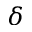<formula> <loc_0><loc_0><loc_500><loc_500>\delta</formula> 